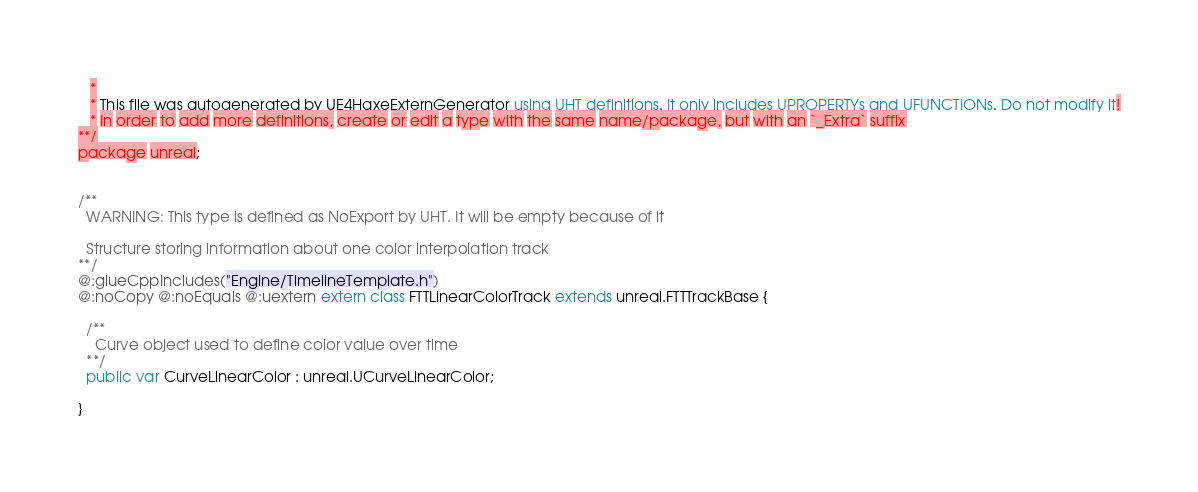Convert code to text. <code><loc_0><loc_0><loc_500><loc_500><_Haxe_>   * 
   * This file was autogenerated by UE4HaxeExternGenerator using UHT definitions. It only includes UPROPERTYs and UFUNCTIONs. Do not modify it!
   * In order to add more definitions, create or edit a type with the same name/package, but with an `_Extra` suffix
**/
package unreal;


/**
  WARNING: This type is defined as NoExport by UHT. It will be empty because of it
  
  Structure storing information about one color interpolation track
**/
@:glueCppIncludes("Engine/TimelineTemplate.h")
@:noCopy @:noEquals @:uextern extern class FTTLinearColorTrack extends unreal.FTTTrackBase {
  
  /**
    Curve object used to define color value over time
  **/
  public var CurveLinearColor : unreal.UCurveLinearColor;
  
}
</code> 